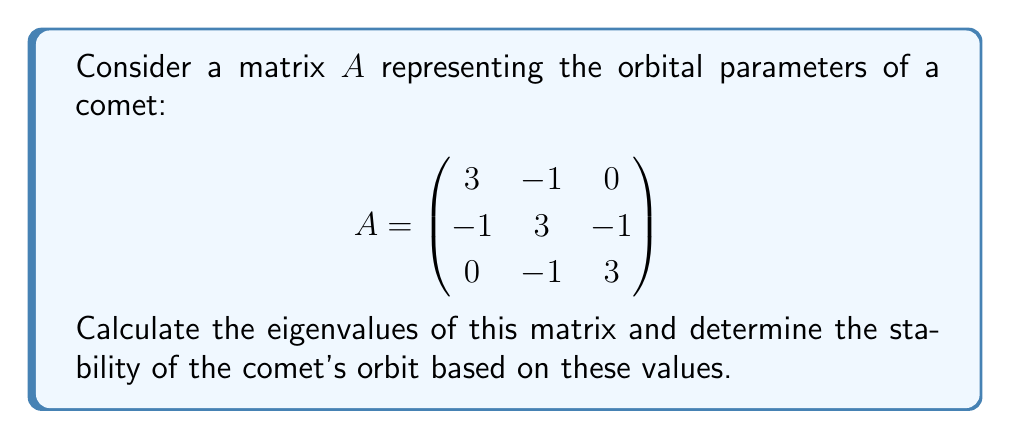Can you solve this math problem? To find the eigenvalues of matrix $A$, we need to solve the characteristic equation:

1) First, we calculate $det(A - \lambda I)$:

   $$det(A - \lambda I) = det\begin{pmatrix}
   3-\lambda & -1 & 0 \\
   -1 & 3-\lambda & -1 \\
   0 & -1 & 3-\lambda
   \end{pmatrix}$$

2) Expanding this determinant:
   
   $$(3-\lambda)[(3-\lambda)(3-\lambda) - 1] - (-1)[(-1)(3-\lambda) - 0] = 0$$

3) Simplifying:

   $(3-\lambda)[(3-\lambda)^2 - 1] + (3-\lambda) = 0$
   
   $(3-\lambda)[(3-\lambda)^2 - 1 + 1] = 0$
   
   $(3-\lambda)(3-\lambda)^2 = 0$

4) Solving this equation:

   $(3-\lambda) = 0$ or $(3-\lambda)^2 = 0$

   $\lambda = 3$ (with algebraic multiplicity 3)

5) Therefore, the only eigenvalue is 3, with algebraic multiplicity 3.

6) For orbital stability: 
   - If all eigenvalues have absolute value less than 1, the orbit is stable.
   - If any eigenvalue has absolute value greater than 1, the orbit is unstable.
   - If the largest eigenvalue has absolute value equal to 1, the orbit is marginally stable.

   Here, the eigenvalue is 3, which has an absolute value greater than 1.
Answer: Eigenvalue: 3 (multiplicity 3). Orbit: Unstable. 